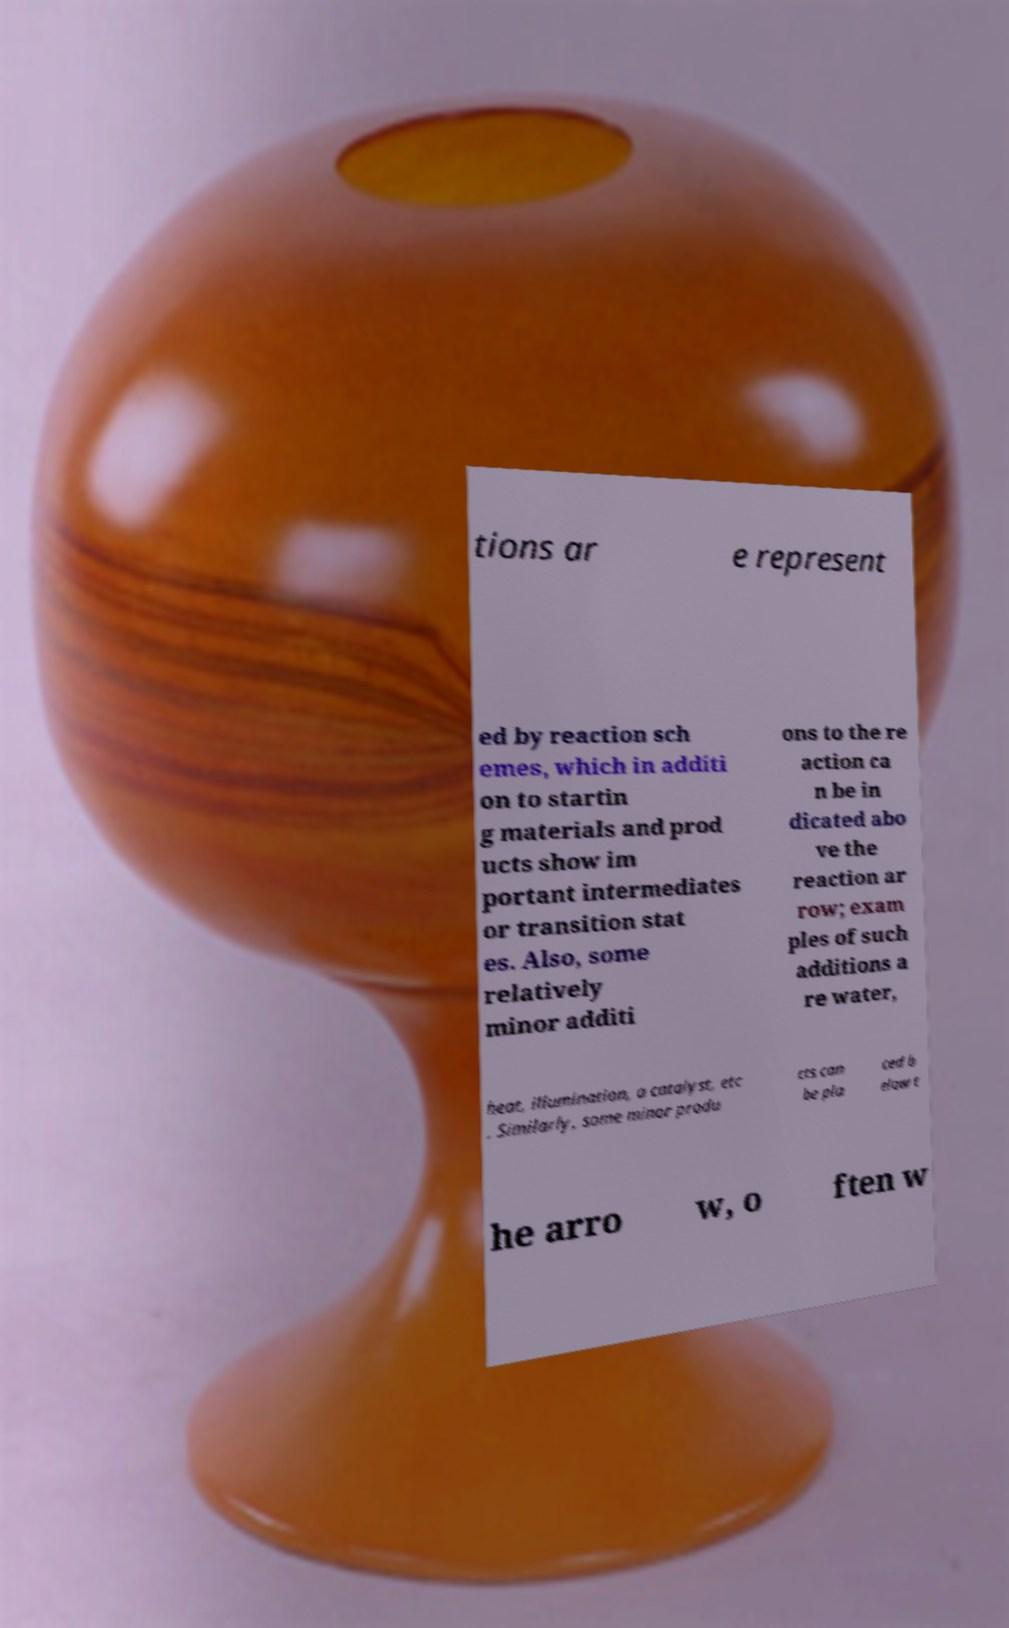What messages or text are displayed in this image? I need them in a readable, typed format. tions ar e represent ed by reaction sch emes, which in additi on to startin g materials and prod ucts show im portant intermediates or transition stat es. Also, some relatively minor additi ons to the re action ca n be in dicated abo ve the reaction ar row; exam ples of such additions a re water, heat, illumination, a catalyst, etc . Similarly, some minor produ cts can be pla ced b elow t he arro w, o ften w 